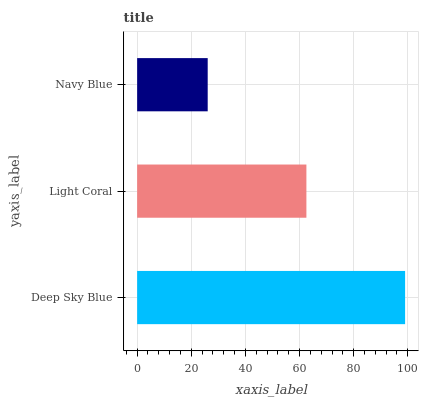Is Navy Blue the minimum?
Answer yes or no. Yes. Is Deep Sky Blue the maximum?
Answer yes or no. Yes. Is Light Coral the minimum?
Answer yes or no. No. Is Light Coral the maximum?
Answer yes or no. No. Is Deep Sky Blue greater than Light Coral?
Answer yes or no. Yes. Is Light Coral less than Deep Sky Blue?
Answer yes or no. Yes. Is Light Coral greater than Deep Sky Blue?
Answer yes or no. No. Is Deep Sky Blue less than Light Coral?
Answer yes or no. No. Is Light Coral the high median?
Answer yes or no. Yes. Is Light Coral the low median?
Answer yes or no. Yes. Is Navy Blue the high median?
Answer yes or no. No. Is Deep Sky Blue the low median?
Answer yes or no. No. 